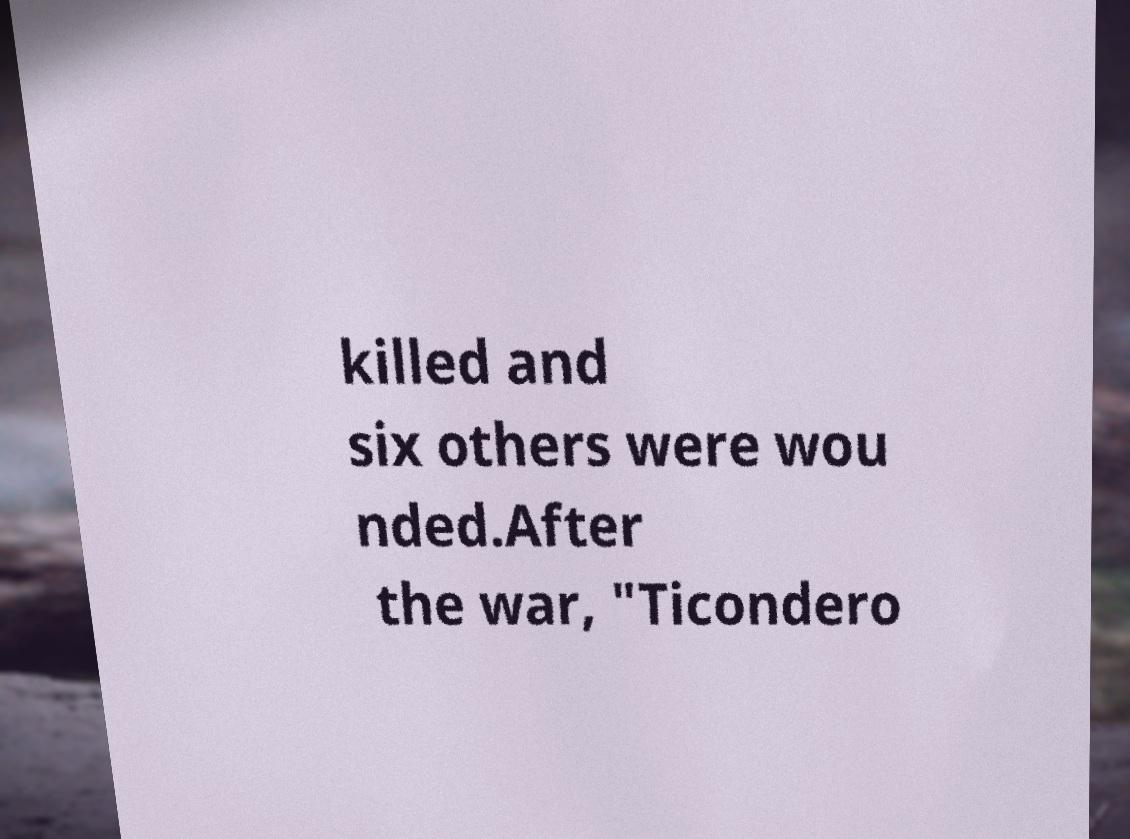Please identify and transcribe the text found in this image. killed and six others were wou nded.After the war, "Ticondero 